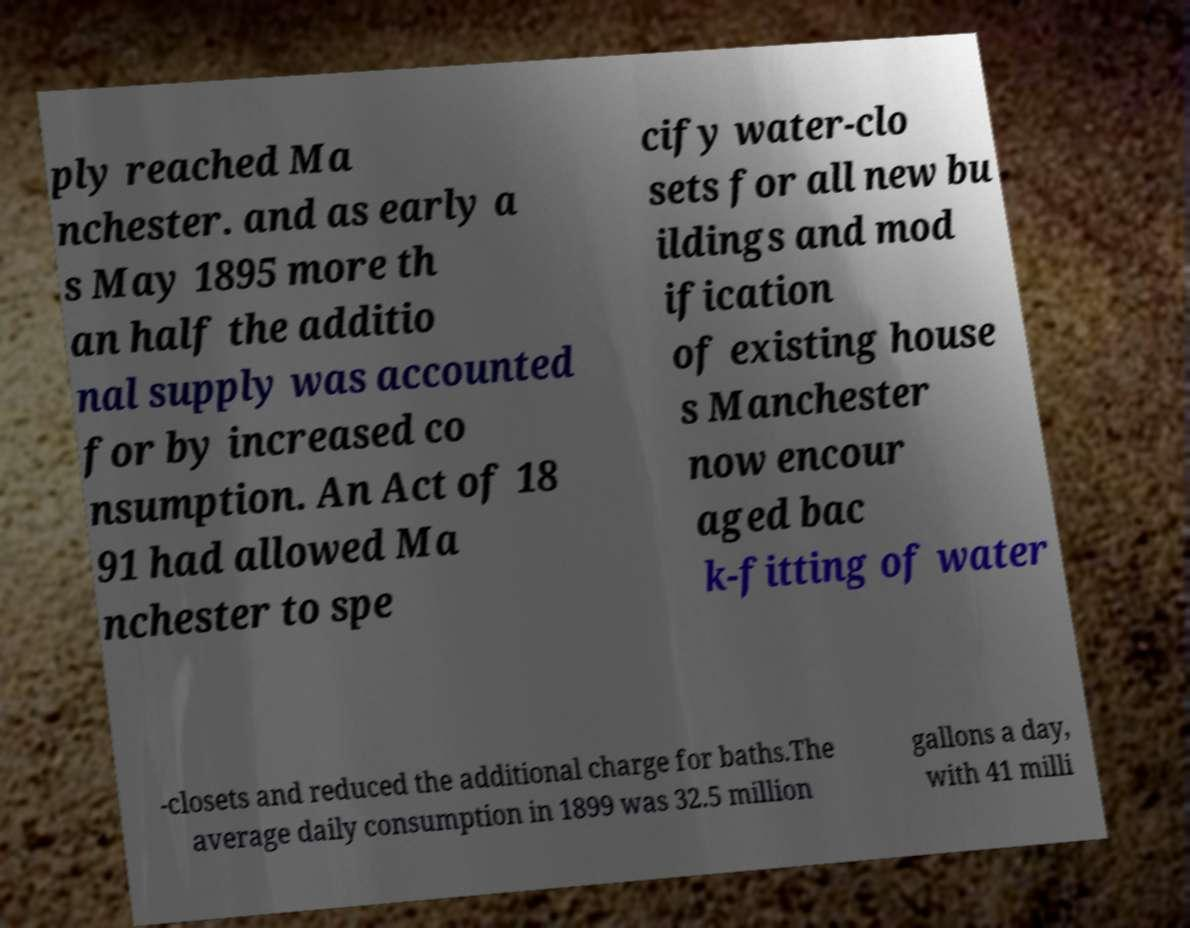For documentation purposes, I need the text within this image transcribed. Could you provide that? ply reached Ma nchester. and as early a s May 1895 more th an half the additio nal supply was accounted for by increased co nsumption. An Act of 18 91 had allowed Ma nchester to spe cify water-clo sets for all new bu ildings and mod ification of existing house s Manchester now encour aged bac k-fitting of water -closets and reduced the additional charge for baths.The average daily consumption in 1899 was 32.5 million gallons a day, with 41 milli 